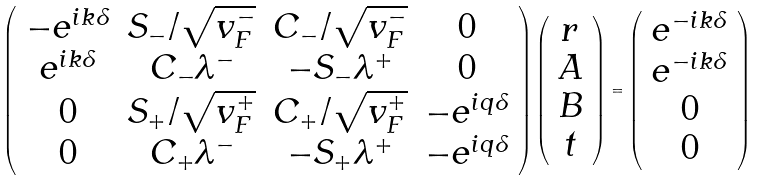<formula> <loc_0><loc_0><loc_500><loc_500>\left ( \begin{array} { c c c c } - e ^ { i k \delta } & S _ { - } / \sqrt { v ^ { - } _ { F } } & C _ { - } / \sqrt { v ^ { - } _ { F } } & 0 \\ e ^ { i k \delta } & C _ { - } \lambda ^ { - } & - S _ { - } \lambda ^ { + } & 0 \\ 0 & S _ { + } / \sqrt { v ^ { + } _ { F } } & C _ { + } / \sqrt { v ^ { + } _ { F } } & - e ^ { i q \delta } \\ 0 & C _ { + } \lambda ^ { - } & - S _ { + } \lambda ^ { + } & - e ^ { i q \delta } \end{array} \right ) \left ( \begin{array} { c } r \\ A \\ B \\ t \end{array} \right ) = \left ( \begin{array} { c } e ^ { - i k \delta } \\ e ^ { - i k \delta } \\ 0 \\ 0 \end{array} \right )</formula> 